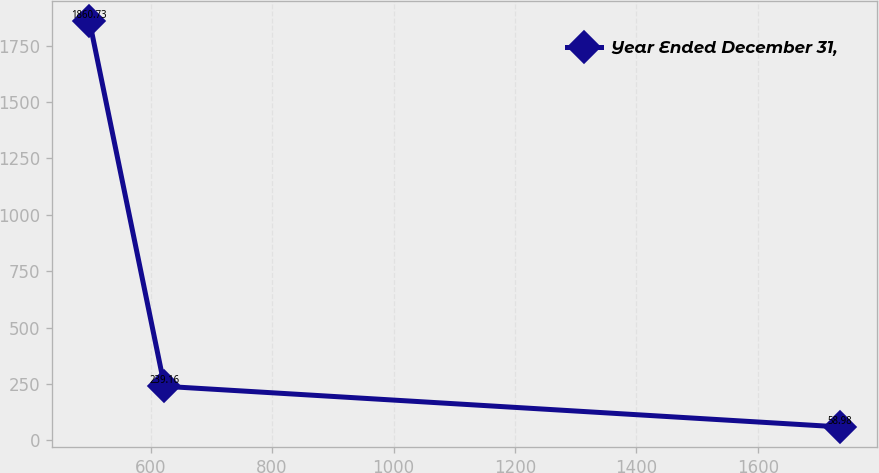<chart> <loc_0><loc_0><loc_500><loc_500><line_chart><ecel><fcel>Year Ended December 31,<nl><fcel>499.19<fcel>1860.73<nl><fcel>622.76<fcel>239.16<nl><fcel>1734.87<fcel>58.98<nl></chart> 